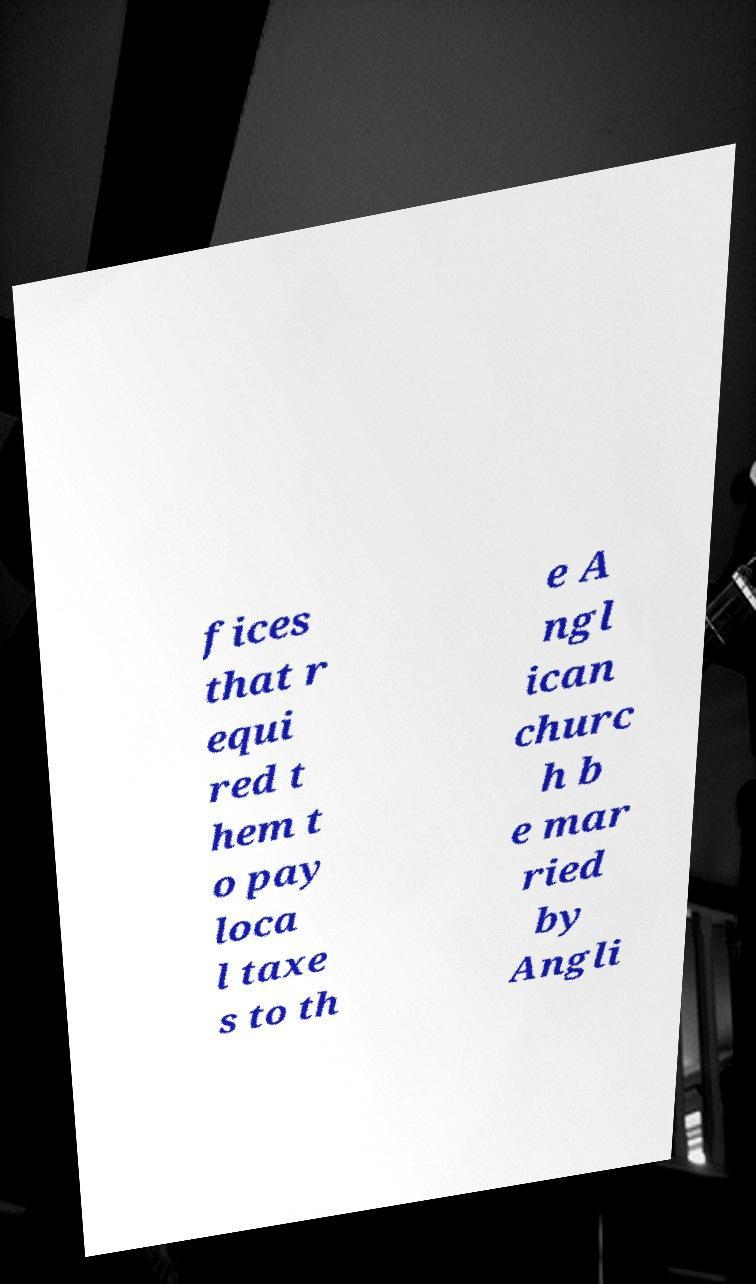For documentation purposes, I need the text within this image transcribed. Could you provide that? fices that r equi red t hem t o pay loca l taxe s to th e A ngl ican churc h b e mar ried by Angli 